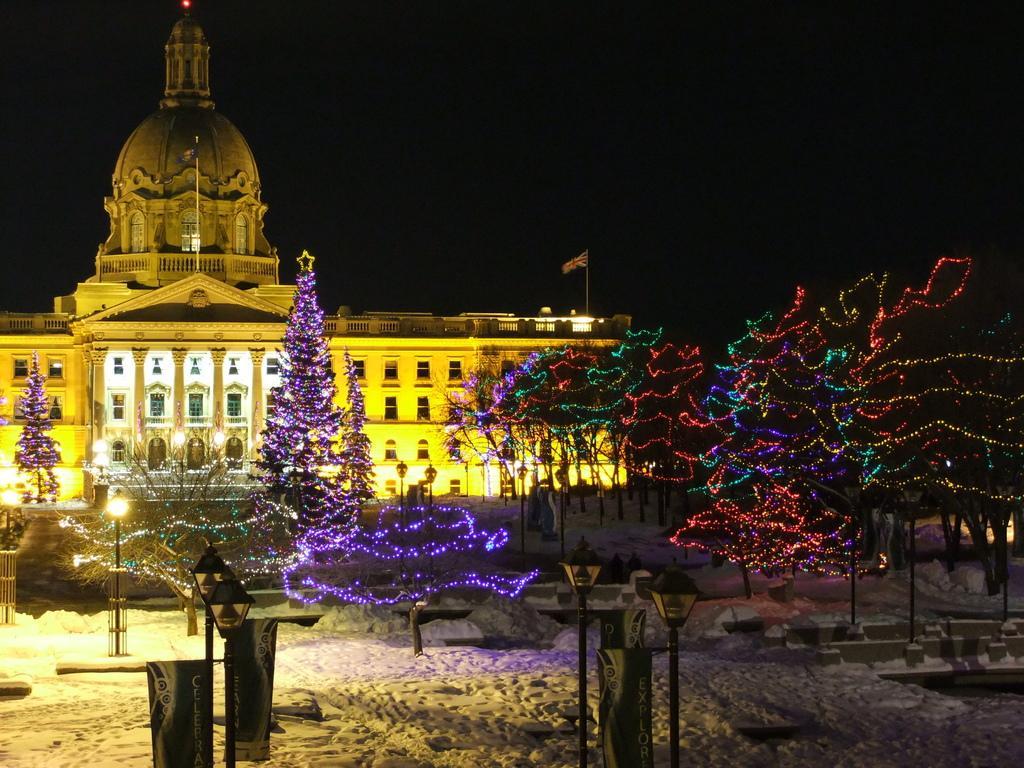Can you describe this image briefly? In this image there is a palace in the background. The picture is taken in the nighttime. There is a flag on the palace. On the right side there are trees with the lights. At the bottom there is snow. There are lamps in the middle. The trees are decorated with the lights. 